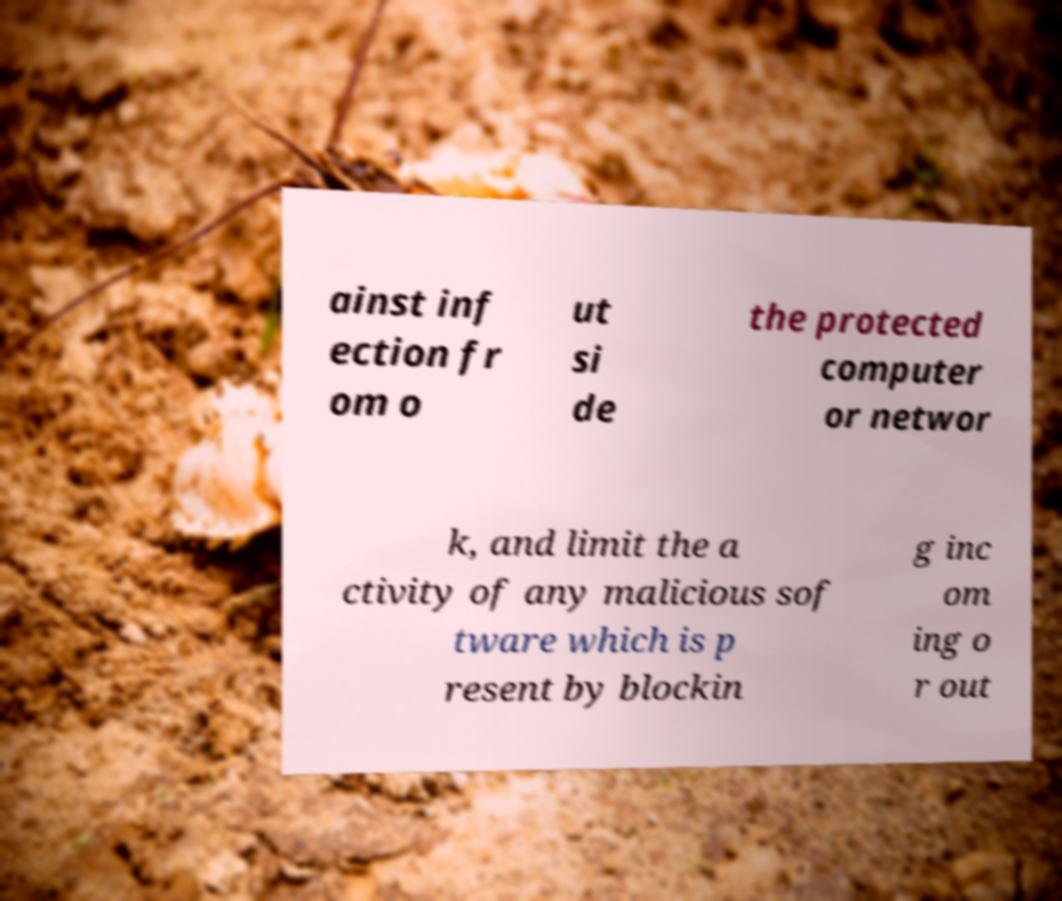Could you assist in decoding the text presented in this image and type it out clearly? ainst inf ection fr om o ut si de the protected computer or networ k, and limit the a ctivity of any malicious sof tware which is p resent by blockin g inc om ing o r out 